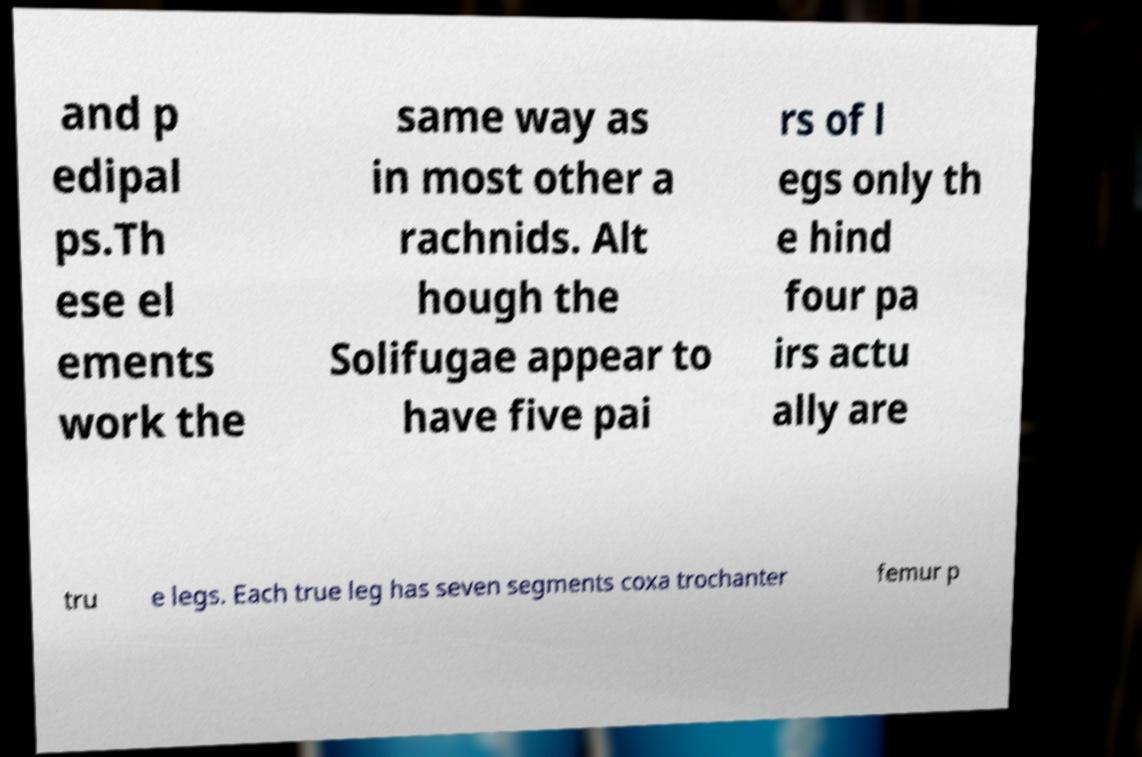Can you accurately transcribe the text from the provided image for me? and p edipal ps.Th ese el ements work the same way as in most other a rachnids. Alt hough the Solifugae appear to have five pai rs of l egs only th e hind four pa irs actu ally are tru e legs. Each true leg has seven segments coxa trochanter femur p 